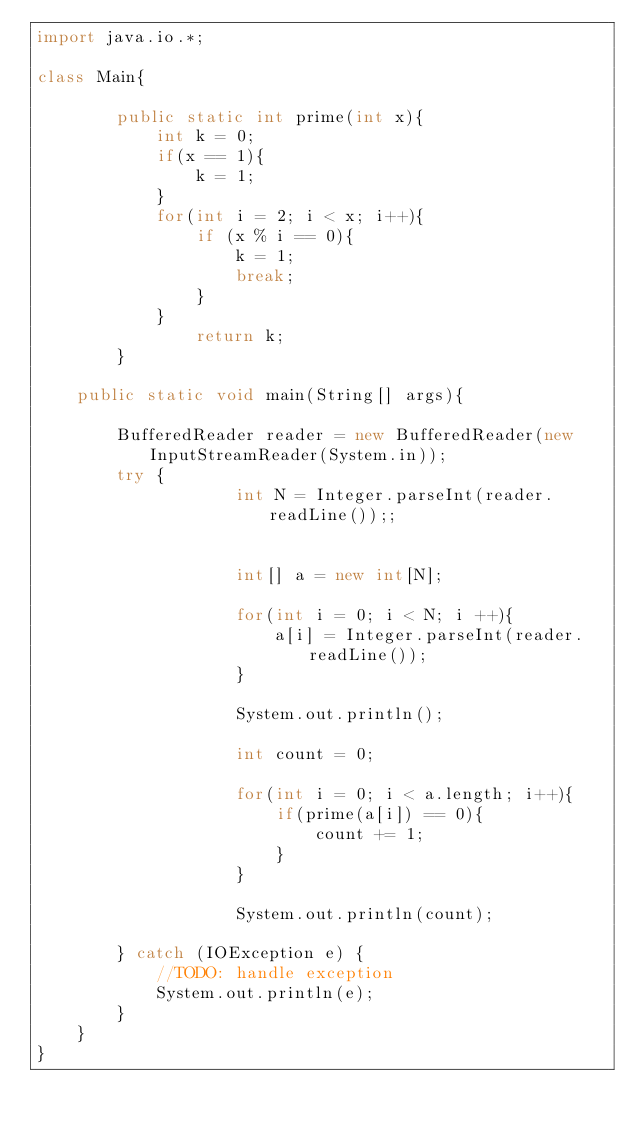Convert code to text. <code><loc_0><loc_0><loc_500><loc_500><_Java_>import java.io.*;

class Main{
    
        public static int prime(int x){
            int k = 0;
            if(x == 1){
                k = 1;
            }
            for(int i = 2; i < x; i++){
                if (x % i == 0){
                    k = 1;
                    break;
                }
            }
                return k;
        }

    public static void main(String[] args){

        BufferedReader reader = new BufferedReader(new InputStreamReader(System.in));
        try {       
                    int N = Integer.parseInt(reader.readLine());;
                    

                    int[] a = new int[N];

                    for(int i = 0; i < N; i ++){
                        a[i] = Integer.parseInt(reader.readLine());
                    }

                    System.out.println();

                    int count = 0;

                    for(int i = 0; i < a.length; i++){
                        if(prime(a[i]) == 0){
                            count += 1;
                        }
                    }

                    System.out.println(count);
                            
        } catch (IOException e) {
            //TODO: handle exception
            System.out.println(e);
        }
    }
}</code> 